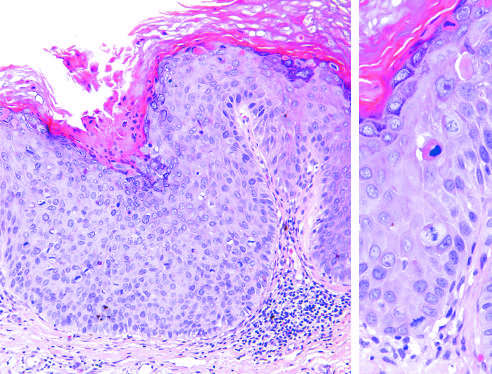does higher magnification show several mitotic figures, some above the basal layer, and nuclear pleomorphism?
Answer the question using a single word or phrase. Yes 